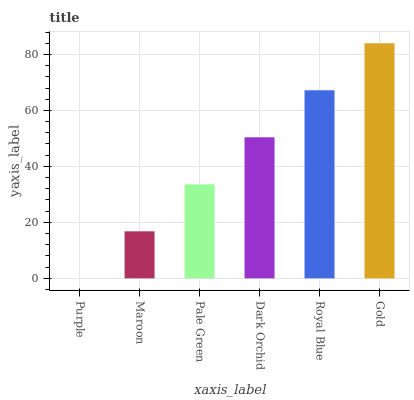Is Purple the minimum?
Answer yes or no. Yes. Is Gold the maximum?
Answer yes or no. Yes. Is Maroon the minimum?
Answer yes or no. No. Is Maroon the maximum?
Answer yes or no. No. Is Maroon greater than Purple?
Answer yes or no. Yes. Is Purple less than Maroon?
Answer yes or no. Yes. Is Purple greater than Maroon?
Answer yes or no. No. Is Maroon less than Purple?
Answer yes or no. No. Is Dark Orchid the high median?
Answer yes or no. Yes. Is Pale Green the low median?
Answer yes or no. Yes. Is Maroon the high median?
Answer yes or no. No. Is Dark Orchid the low median?
Answer yes or no. No. 